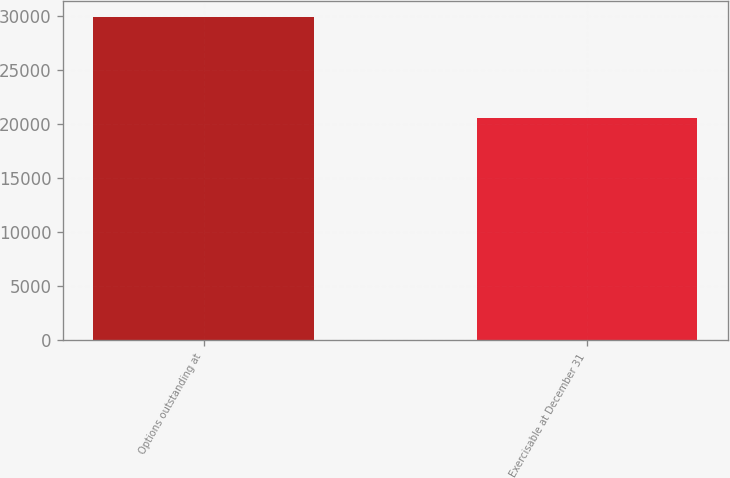Convert chart. <chart><loc_0><loc_0><loc_500><loc_500><bar_chart><fcel>Options outstanding at<fcel>Exercisable at December 31<nl><fcel>29946<fcel>20610<nl></chart> 